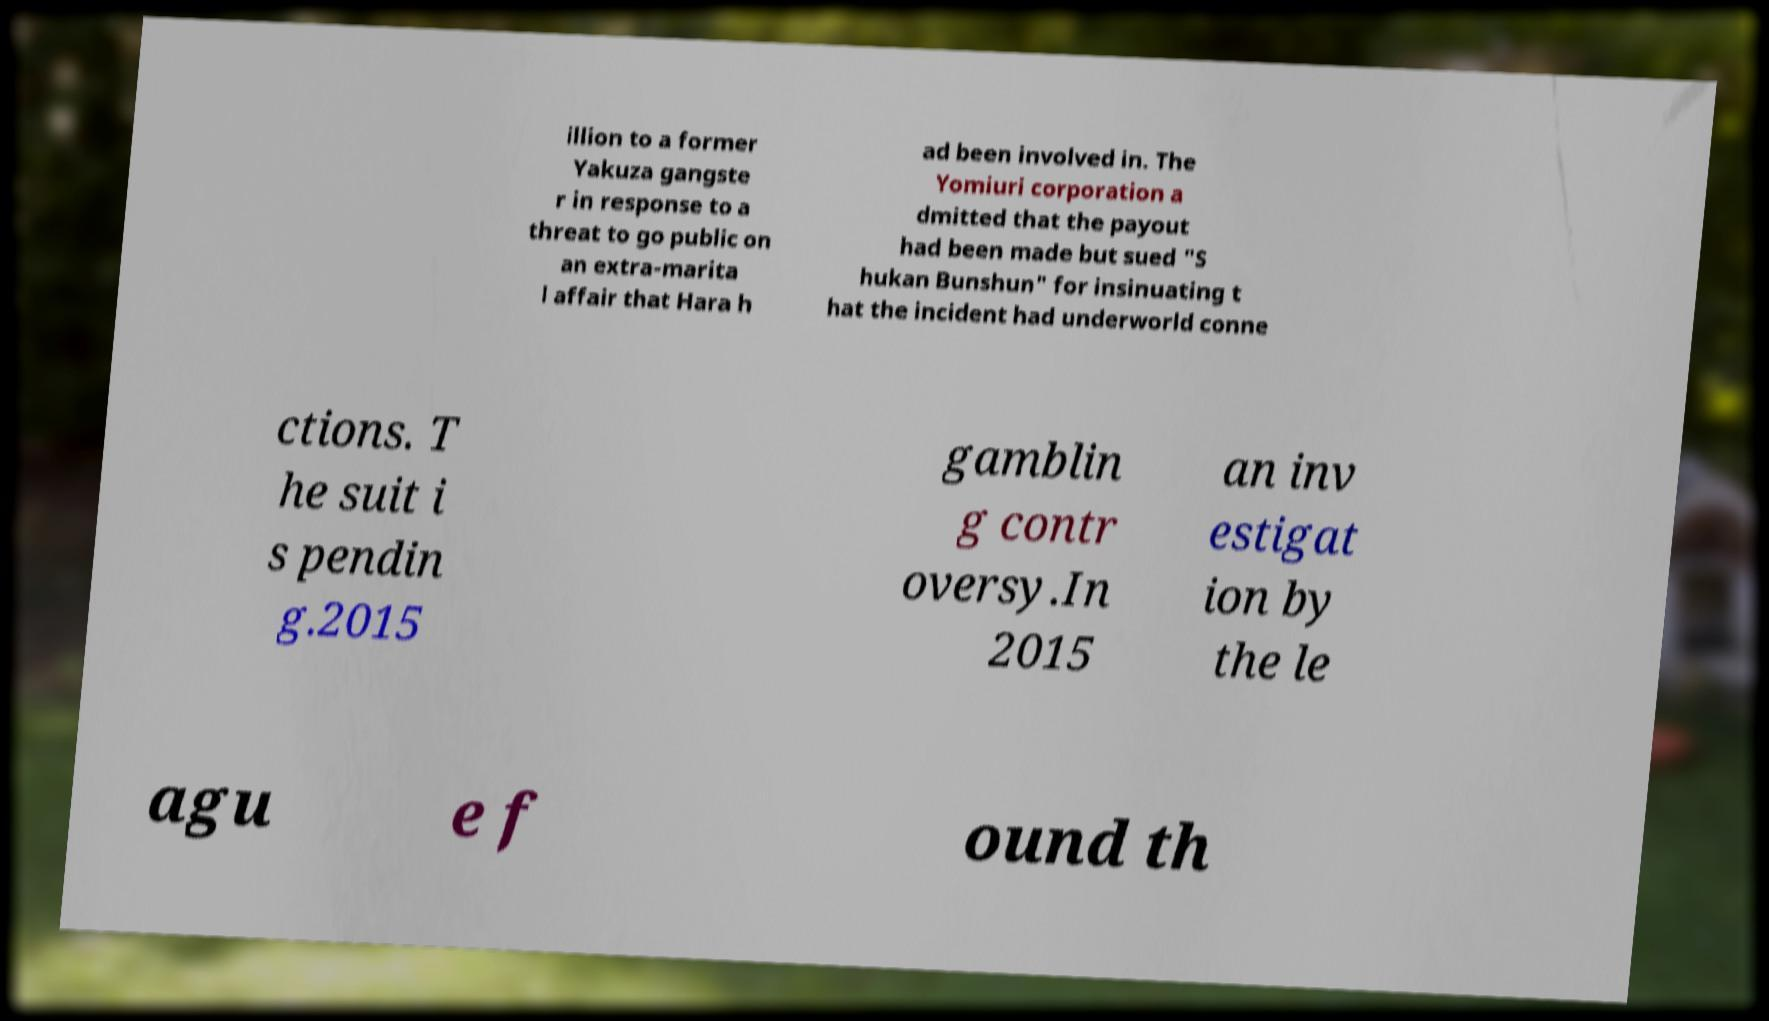Please read and relay the text visible in this image. What does it say? illion to a former Yakuza gangste r in response to a threat to go public on an extra-marita l affair that Hara h ad been involved in. The Yomiuri corporation a dmitted that the payout had been made but sued "S hukan Bunshun" for insinuating t hat the incident had underworld conne ctions. T he suit i s pendin g.2015 gamblin g contr oversy.In 2015 an inv estigat ion by the le agu e f ound th 